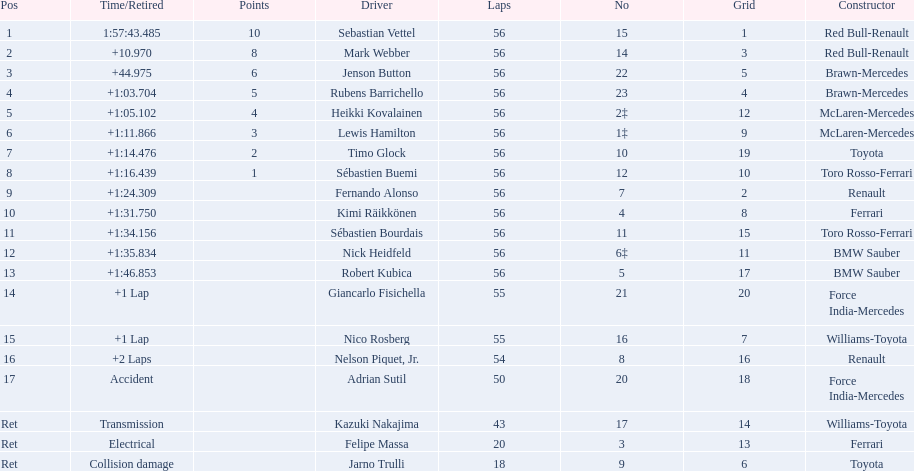Which drive retired because of electrical issues? Felipe Massa. Which driver retired due to accident? Adrian Sutil. Which driver retired due to collision damage? Jarno Trulli. 